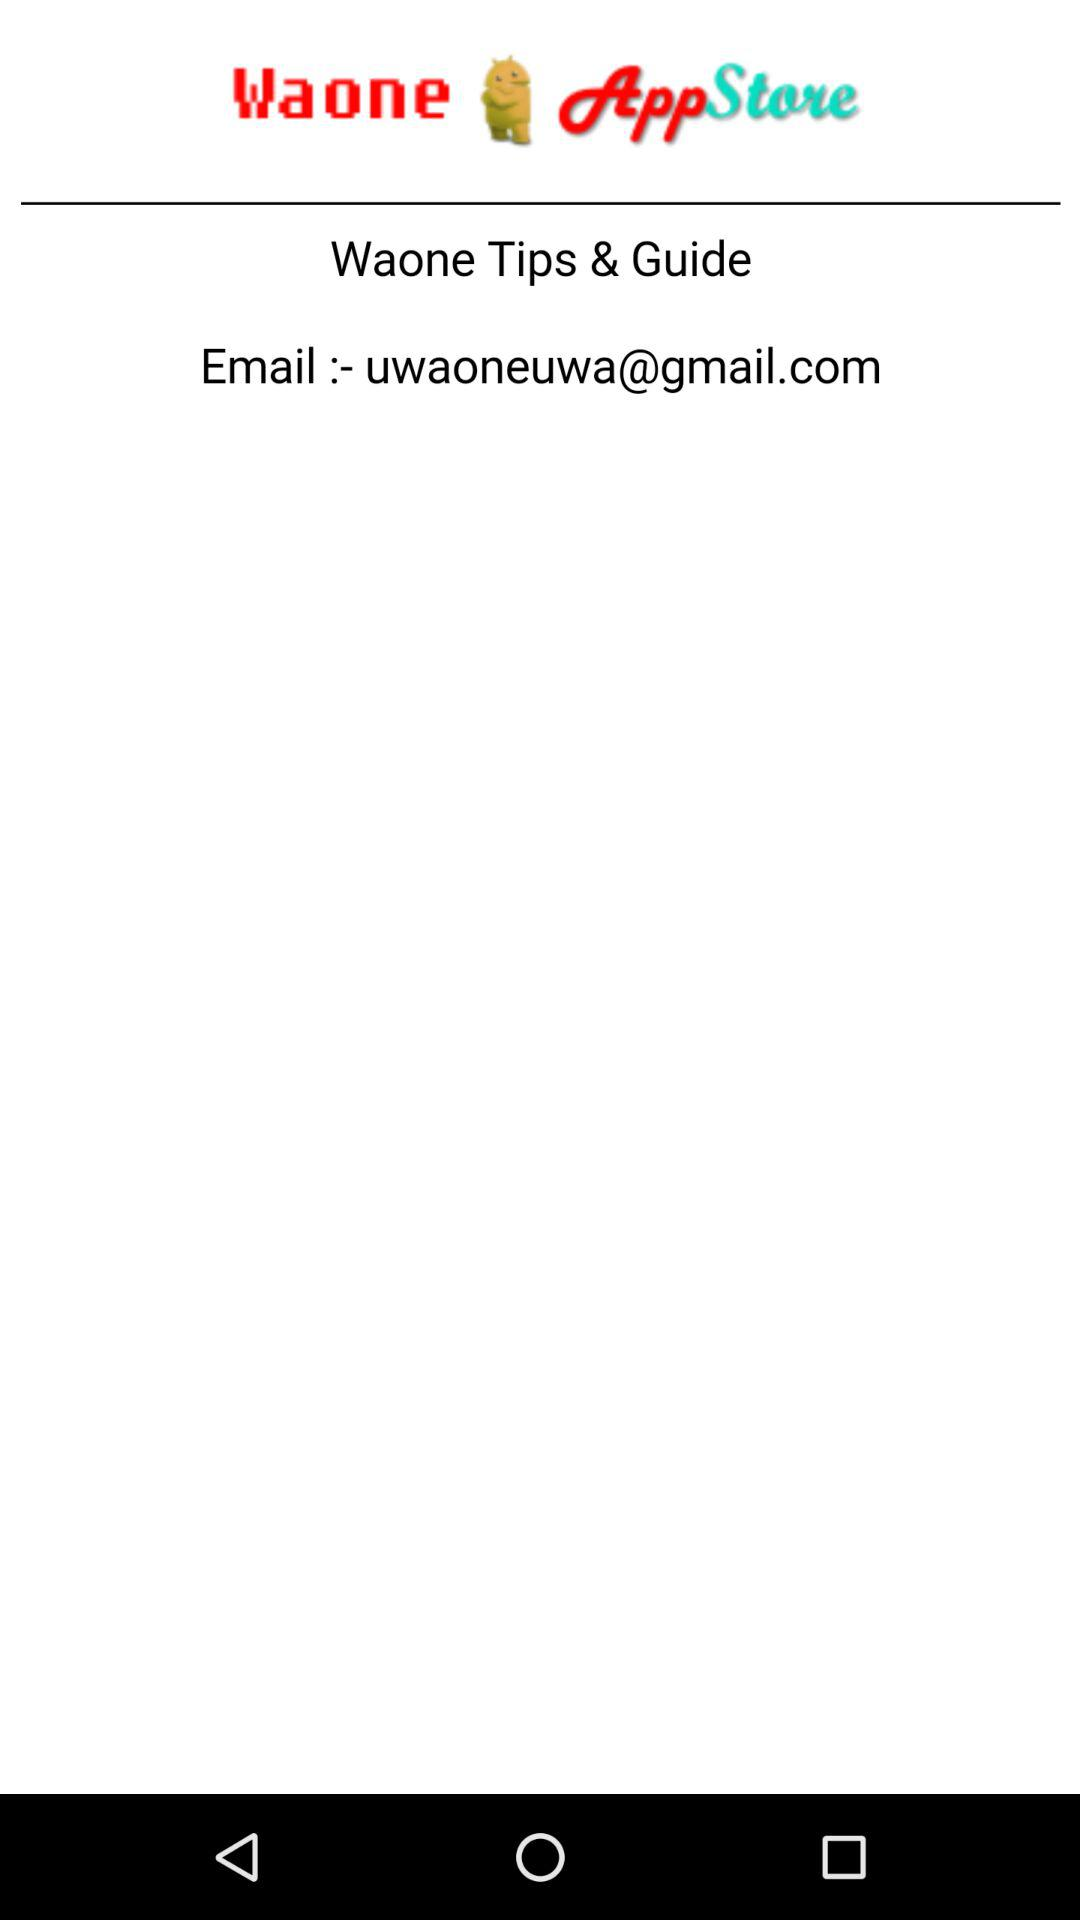What is the given email address? The given email address is uwaoneuwa@gmail.com. 